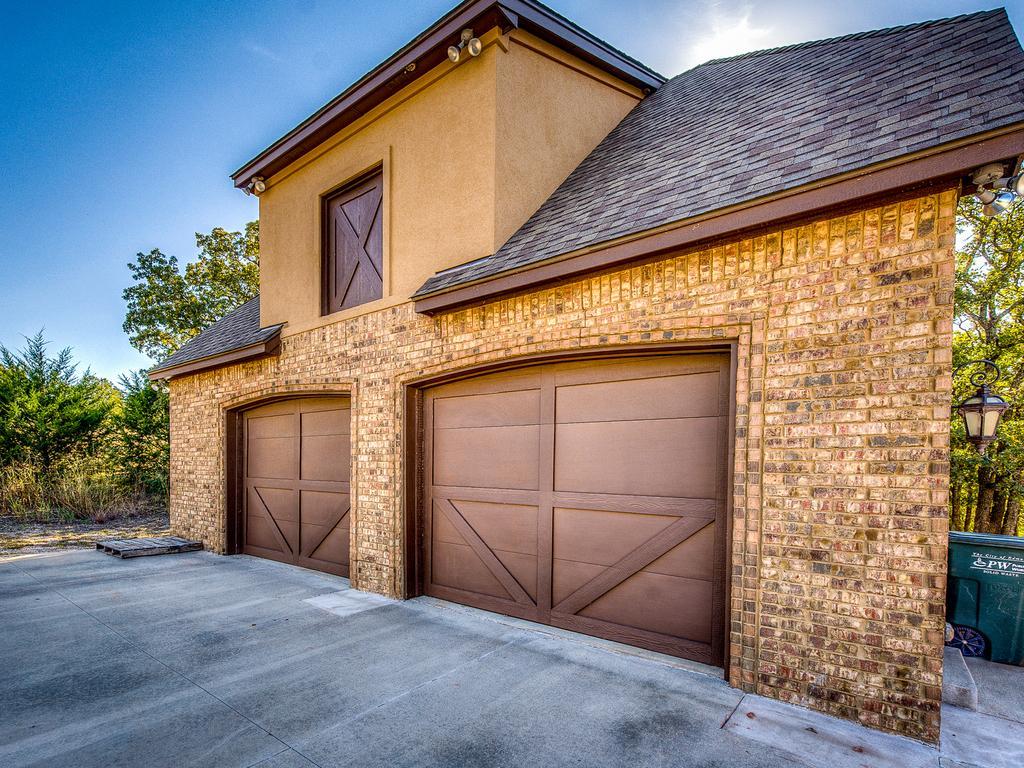How would you summarize this image in a sentence or two? In this image we can see a house. In the background of the image there are trees and the sky. On the right side of the image there is a light, moving big, trees and other objects. At the bottom of the image there is the floor. 